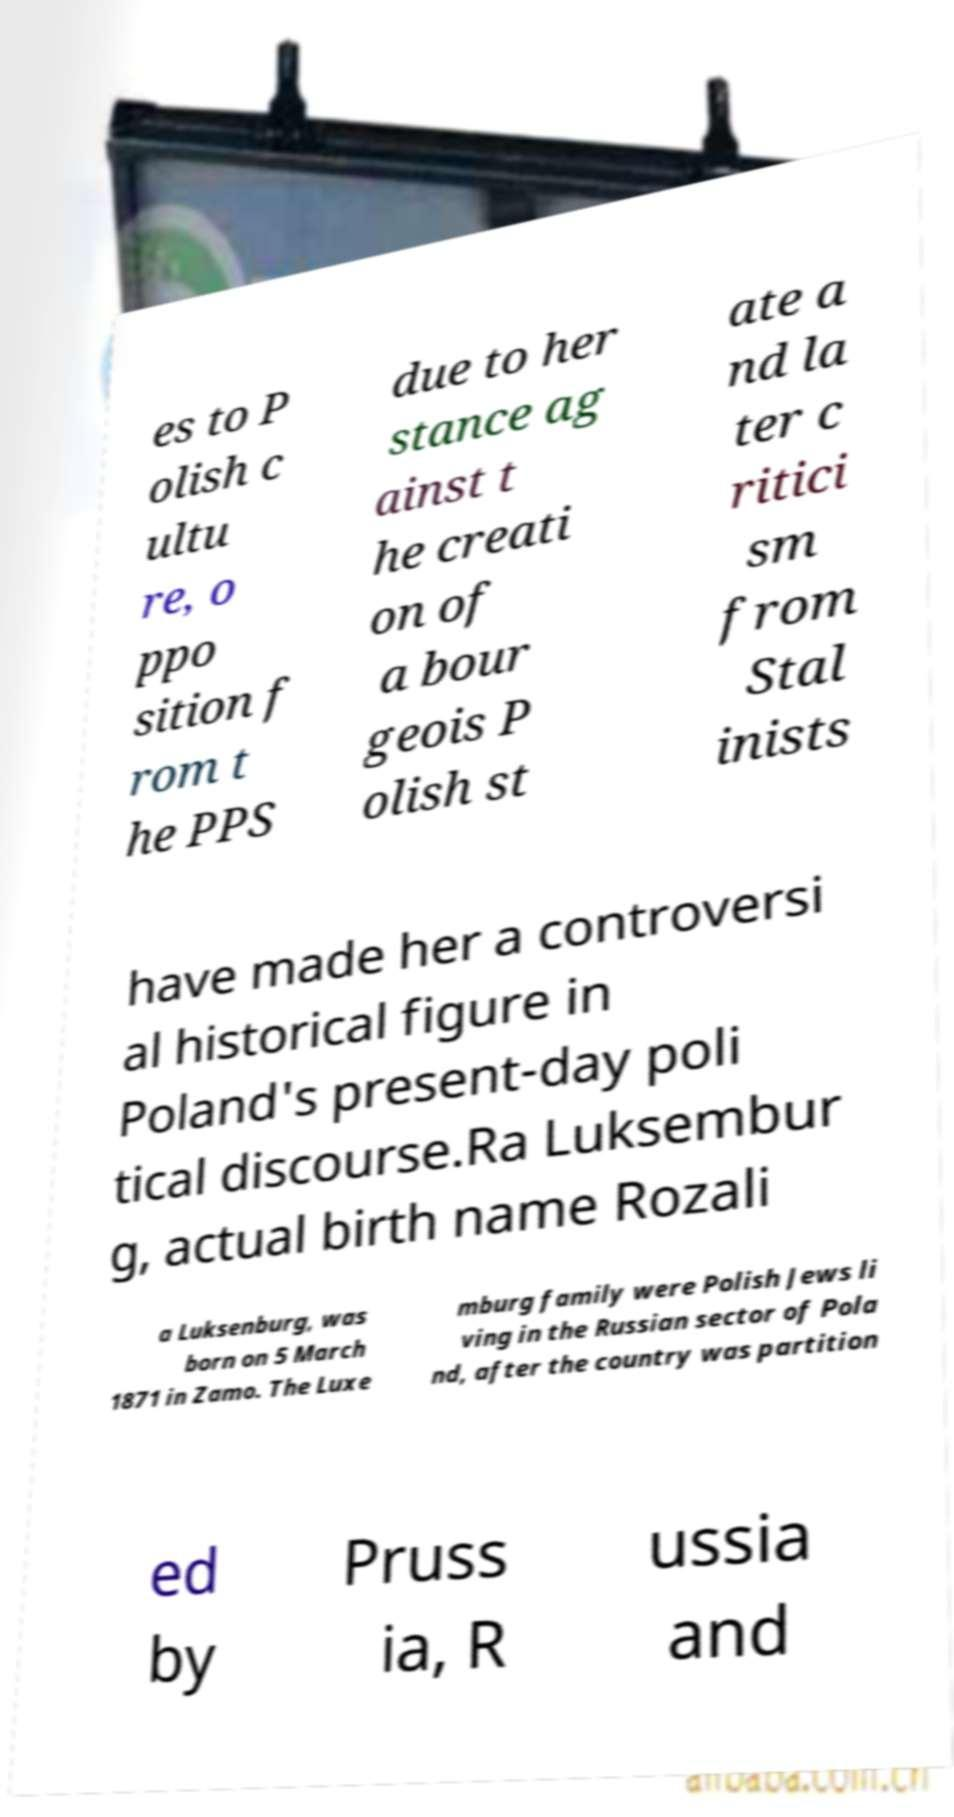Please read and relay the text visible in this image. What does it say? es to P olish c ultu re, o ppo sition f rom t he PPS due to her stance ag ainst t he creati on of a bour geois P olish st ate a nd la ter c ritici sm from Stal inists have made her a controversi al historical figure in Poland's present-day poli tical discourse.Ra Luksembur g, actual birth name Rozali a Luksenburg, was born on 5 March 1871 in Zamo. The Luxe mburg family were Polish Jews li ving in the Russian sector of Pola nd, after the country was partition ed by Pruss ia, R ussia and 